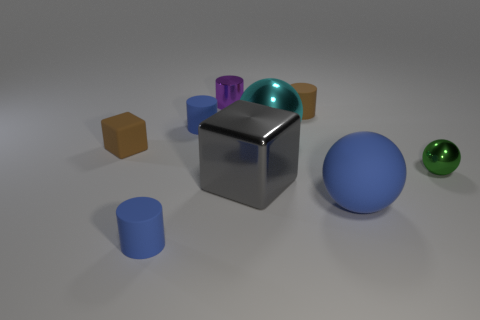Subtract all small purple cylinders. How many cylinders are left? 3 Add 1 small purple shiny things. How many objects exist? 10 Subtract all blocks. How many objects are left? 7 Subtract all yellow spheres. How many blue cylinders are left? 2 Subtract all green spheres. How many spheres are left? 2 Add 5 small brown cubes. How many small brown cubes are left? 6 Add 9 large blue rubber objects. How many large blue rubber objects exist? 10 Subtract 0 red blocks. How many objects are left? 9 Subtract 1 cubes. How many cubes are left? 1 Subtract all brown cylinders. Subtract all yellow balls. How many cylinders are left? 3 